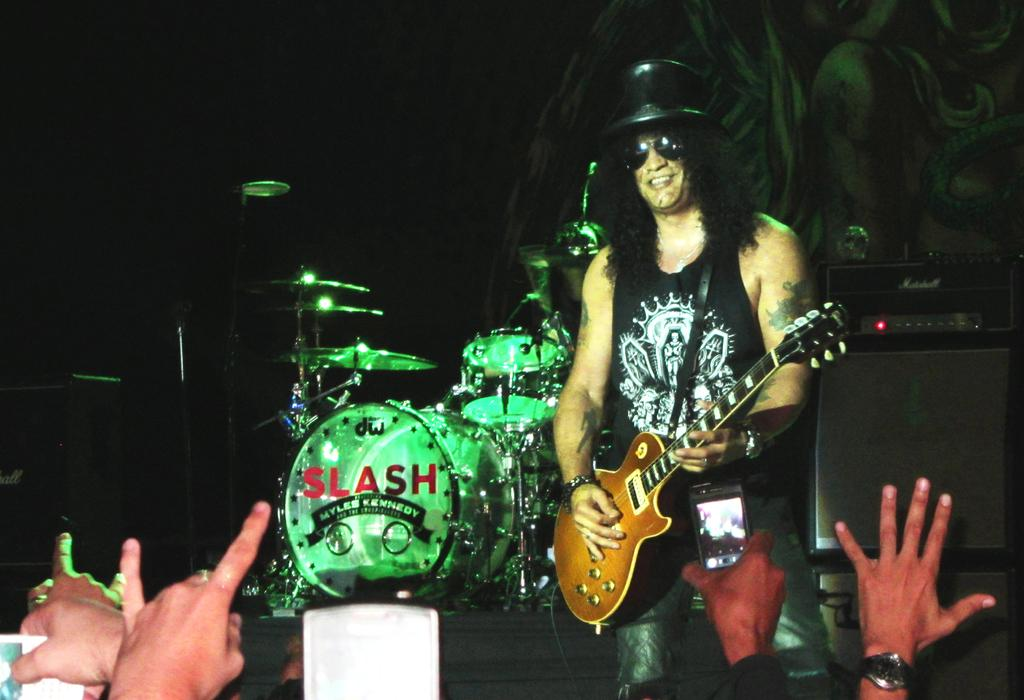What is the man in the image doing? The man is playing a guitar. How is the man positioned in the image? The man is standing. What other musical instrument can be seen in the background of the image? There are drums in the background of the image. Are there any other people visible in the image? Yes, there are persons in the background of the image. What type of snow can be seen falling in the image? There is no snow present in the image. How does the man's behavior change when he sees the top of the mountain in the image? There is no mountain or change in behavior mentioned in the image. 